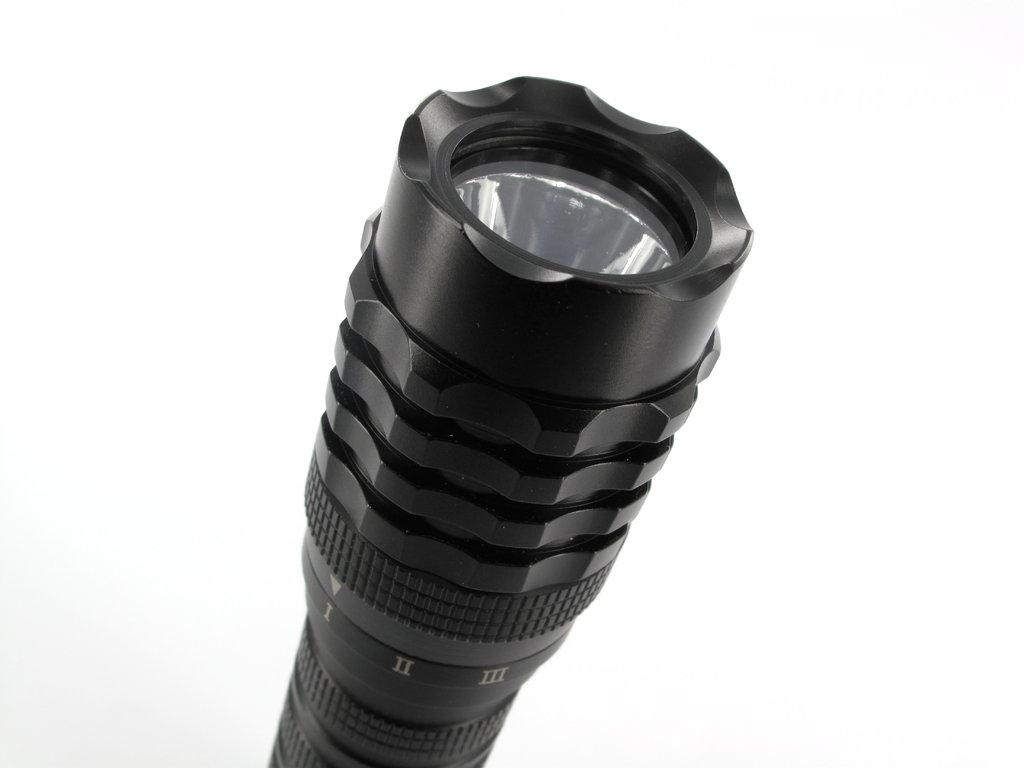What type of object is present in the image? There is a black color torch light in the image. Can you describe the appearance of the object? The torch light is black in color. What type of currency exchange is taking place in the image? There is no currency exchange or any financial transaction depicted in the image; it only features a black color torch light. 